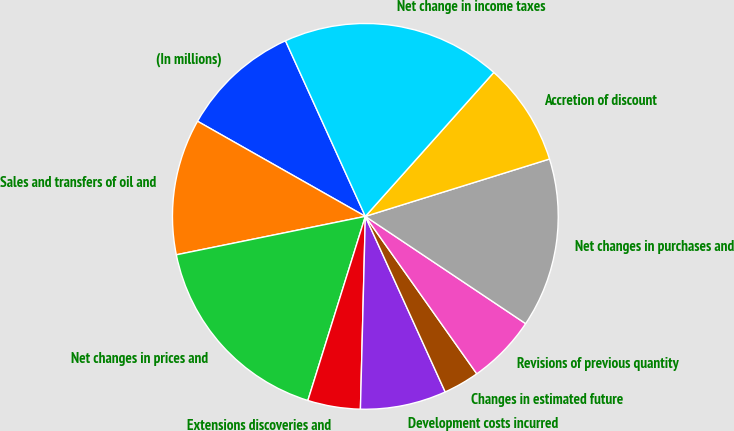Convert chart to OTSL. <chart><loc_0><loc_0><loc_500><loc_500><pie_chart><fcel>(In millions)<fcel>Sales and transfers of oil and<fcel>Net changes in prices and<fcel>Extensions discoveries and<fcel>Development costs incurred<fcel>Changes in estimated future<fcel>Revisions of previous quantity<fcel>Net changes in purchases and<fcel>Accretion of discount<fcel>Net change in income taxes<nl><fcel>10.0%<fcel>11.4%<fcel>16.99%<fcel>4.41%<fcel>7.2%<fcel>3.01%<fcel>5.81%<fcel>14.19%<fcel>8.6%<fcel>18.39%<nl></chart> 